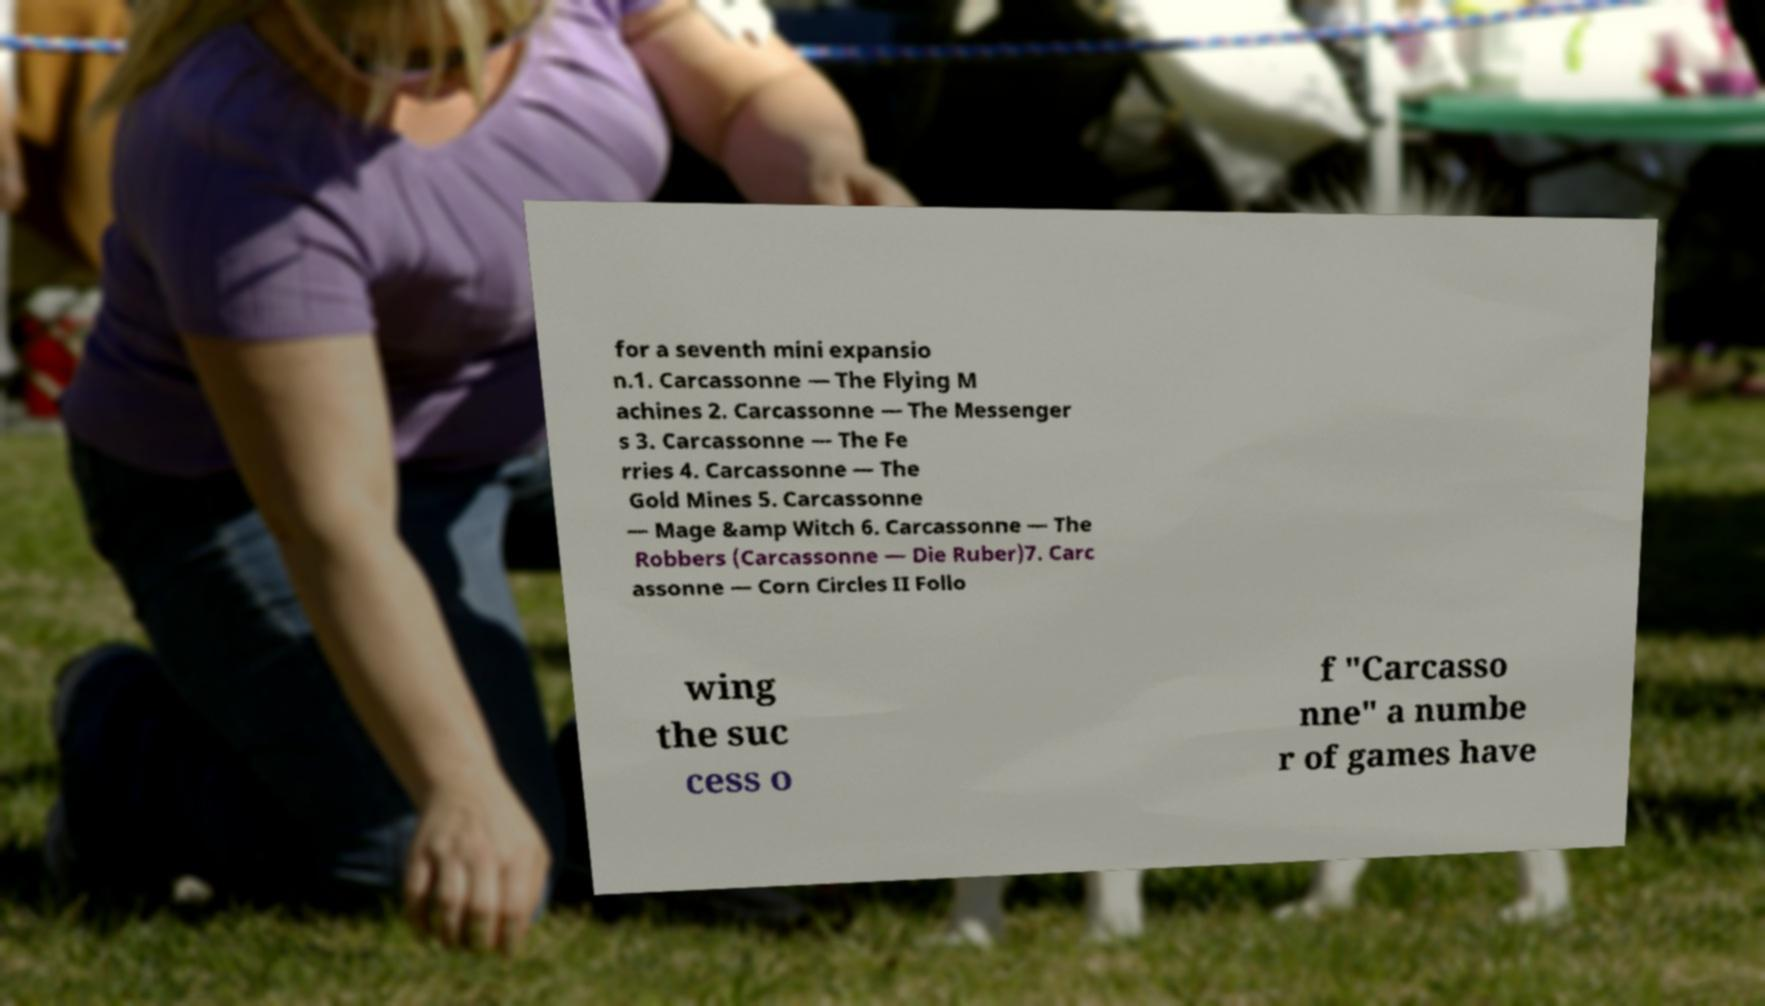For documentation purposes, I need the text within this image transcribed. Could you provide that? for a seventh mini expansio n.1. Carcassonne — The Flying M achines 2. Carcassonne — The Messenger s 3. Carcassonne — The Fe rries 4. Carcassonne — The Gold Mines 5. Carcassonne — Mage &amp Witch 6. Carcassonne — The Robbers (Carcassonne — Die Ruber)7. Carc assonne — Corn Circles II Follo wing the suc cess o f "Carcasso nne" a numbe r of games have 